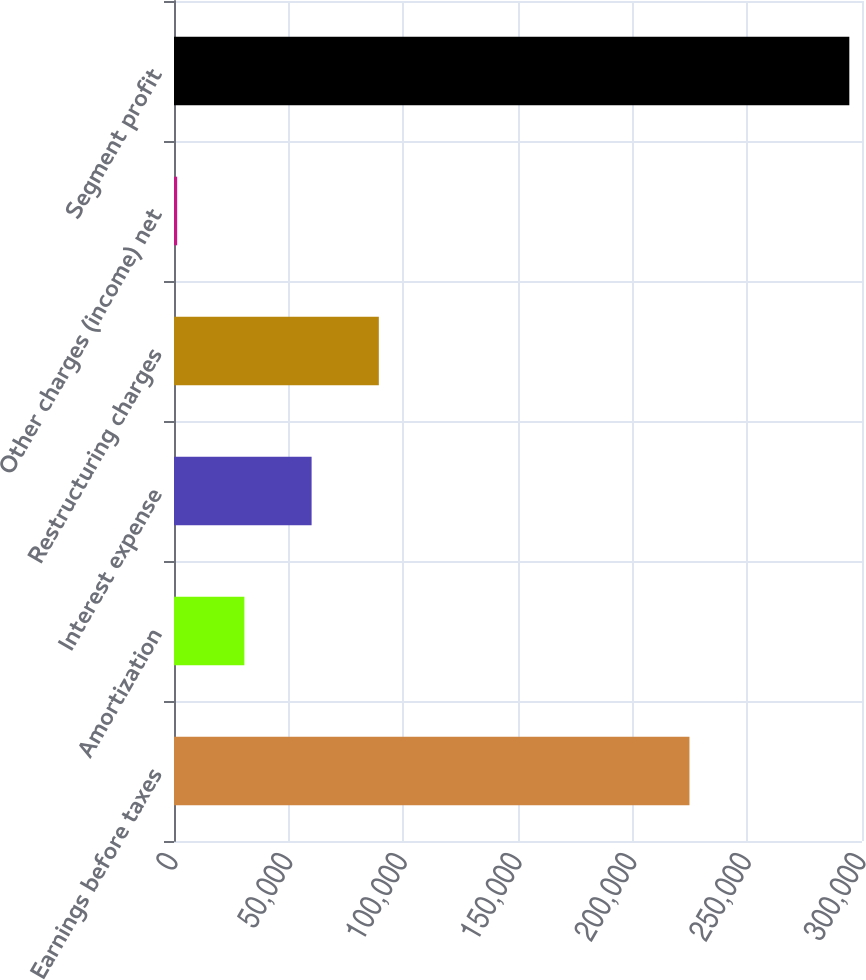Convert chart to OTSL. <chart><loc_0><loc_0><loc_500><loc_500><bar_chart><fcel>Earnings before taxes<fcel>Amortization<fcel>Interest expense<fcel>Restructuring charges<fcel>Other charges (income) net<fcel>Segment profit<nl><fcel>224762<fcel>30693.1<fcel>60002.2<fcel>89311.3<fcel>1384<fcel>294475<nl></chart> 